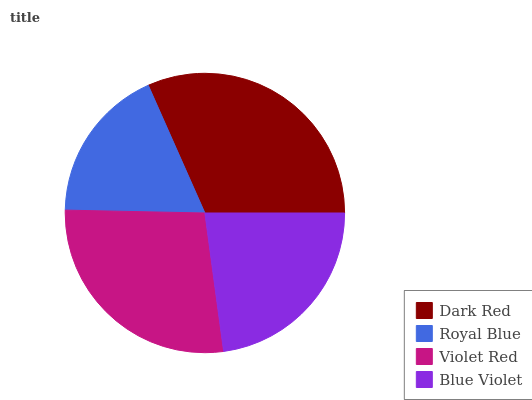Is Royal Blue the minimum?
Answer yes or no. Yes. Is Dark Red the maximum?
Answer yes or no. Yes. Is Violet Red the minimum?
Answer yes or no. No. Is Violet Red the maximum?
Answer yes or no. No. Is Violet Red greater than Royal Blue?
Answer yes or no. Yes. Is Royal Blue less than Violet Red?
Answer yes or no. Yes. Is Royal Blue greater than Violet Red?
Answer yes or no. No. Is Violet Red less than Royal Blue?
Answer yes or no. No. Is Violet Red the high median?
Answer yes or no. Yes. Is Blue Violet the low median?
Answer yes or no. Yes. Is Dark Red the high median?
Answer yes or no. No. Is Violet Red the low median?
Answer yes or no. No. 